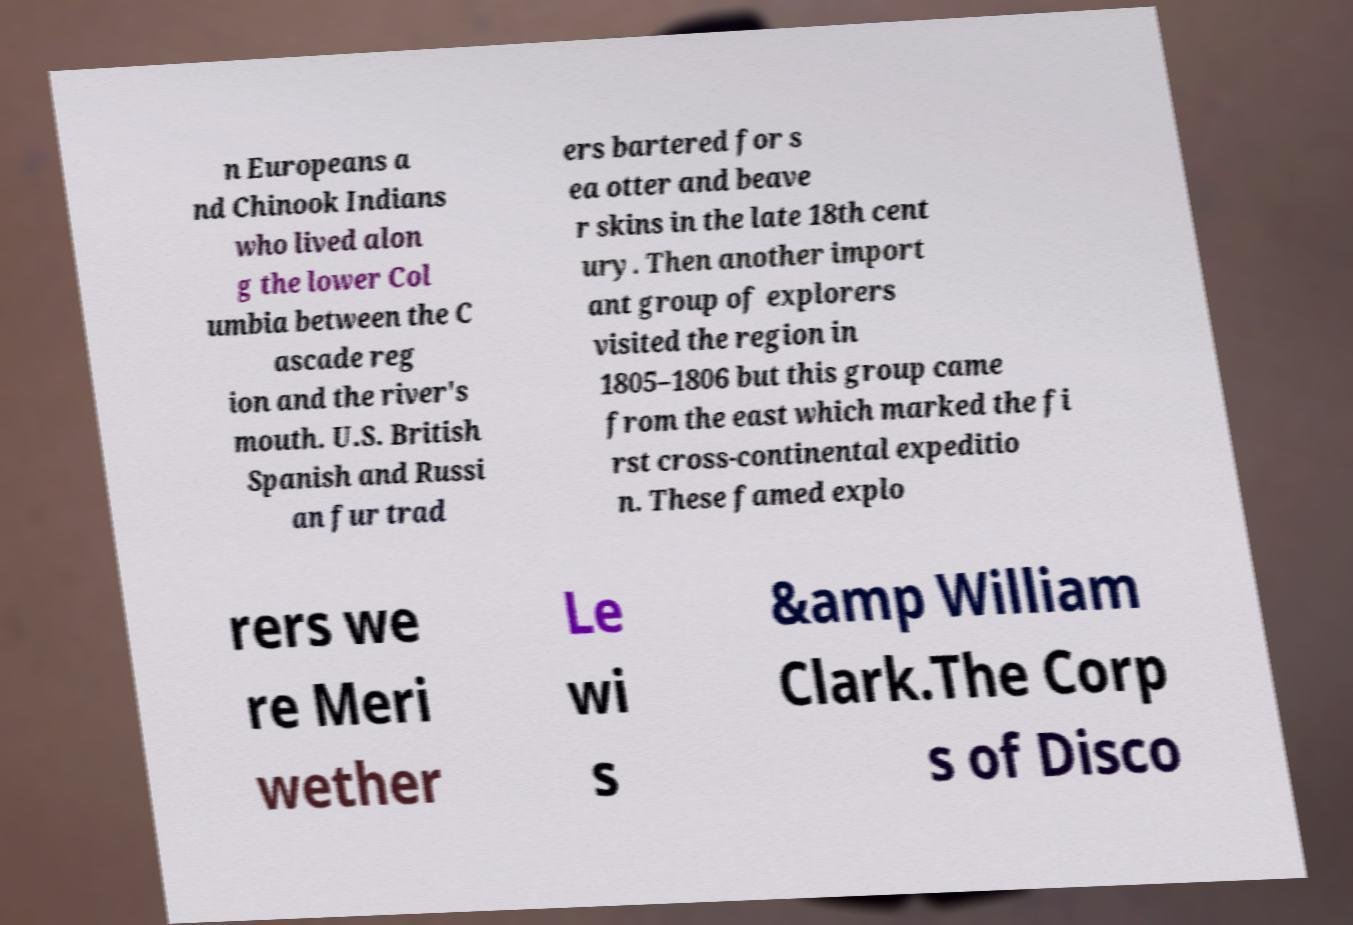Can you accurately transcribe the text from the provided image for me? n Europeans a nd Chinook Indians who lived alon g the lower Col umbia between the C ascade reg ion and the river's mouth. U.S. British Spanish and Russi an fur trad ers bartered for s ea otter and beave r skins in the late 18th cent ury. Then another import ant group of explorers visited the region in 1805–1806 but this group came from the east which marked the fi rst cross-continental expeditio n. These famed explo rers we re Meri wether Le wi s &amp William Clark.The Corp s of Disco 